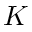<formula> <loc_0><loc_0><loc_500><loc_500>K</formula> 